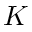<formula> <loc_0><loc_0><loc_500><loc_500>K</formula> 